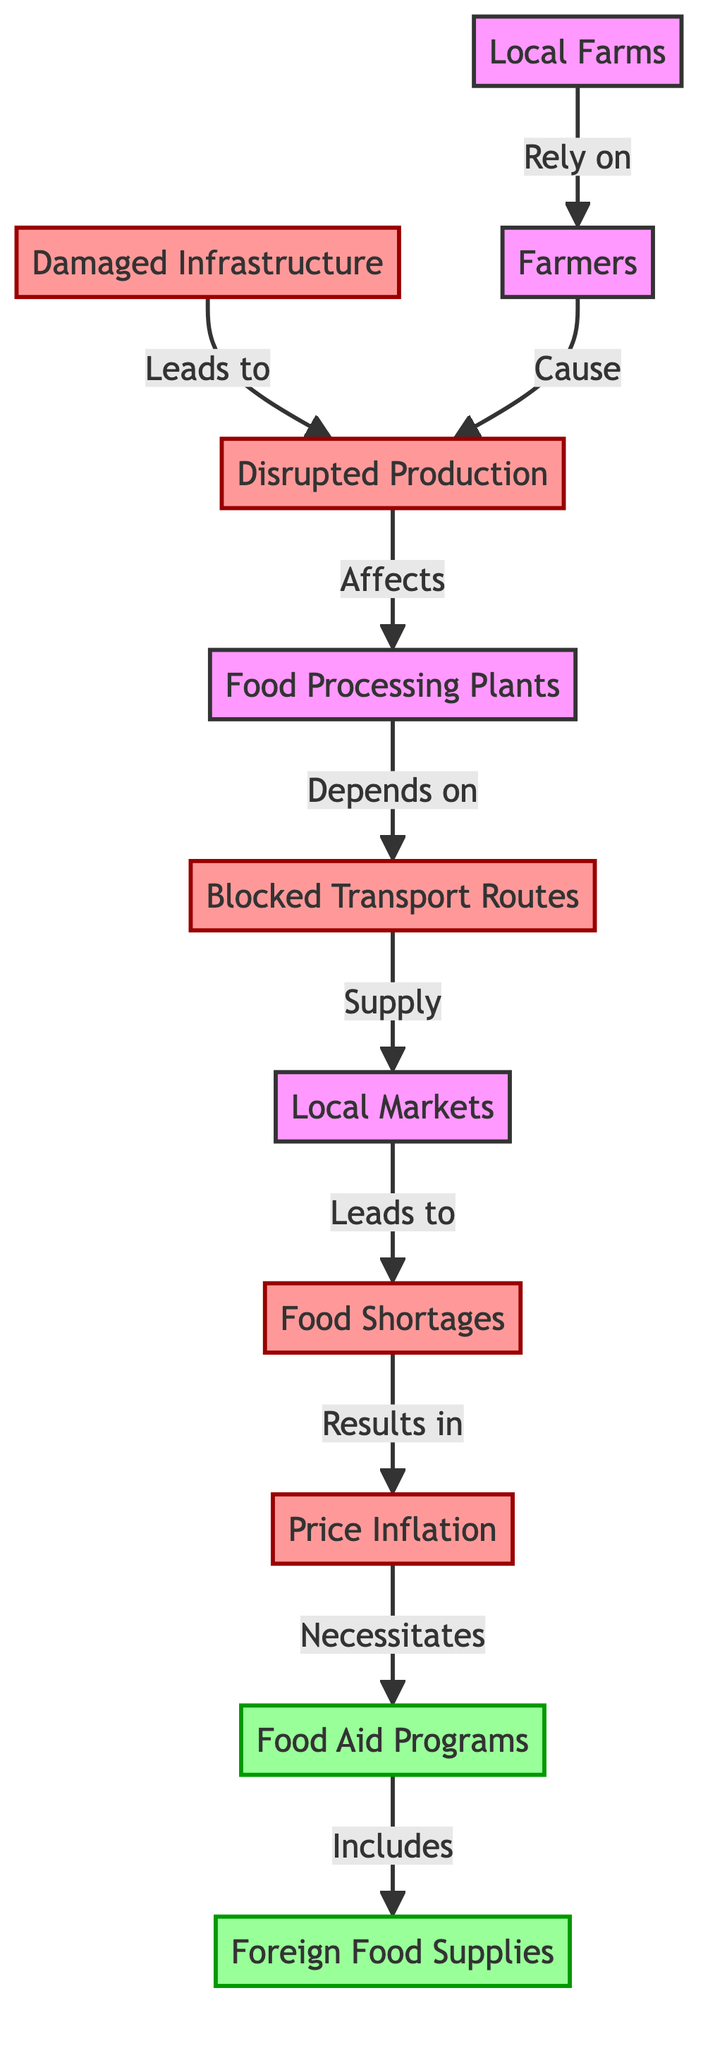What is the first node in the diagram? The first node in the diagram is "Local Farms", which is the starting point for the flow of dependency leading to various impacts due to war.
Answer: Local Farms How many total nodes are there in the diagram? There are a total of 9 nodes represented in the diagram, including "Local Farms", "Farmers", "Damaged Infrastructure", "Disrupted Production", "Food Processing Plants", "Blocked Transport Routes", "Local Markets", "Food Shortages", and "Price Inflation".
Answer: 9 What node is affected by both "Farmers" and "Damaged Infrastructure"? The node affected by both "Farmers" and "Damaged Infrastructure" is "Disrupted Production", as both contribute to the disruption in production.
Answer: Disrupted Production Which node directly leads to "Food Shortages"? The node that directly leads to "Food Shortages" is "Local Markets", as it is the point where the availability of food influences shortages.
Answer: Local Markets What is the relationship between "Price Inflation" and "Food Aid Programs"? The relationship is that "Price Inflation" necessitates "Food Aid Programs", indicating that inflation in food prices triggers the need for external assistance.
Answer: Necessitates Explain how "Blocked Transport Routes" influences food supply. "Blocked Transport Routes" directly influences food supply by hindering the transportation of goods from "Food Processing Plants" to "Local Markets". This blockage can create delays or shortages in food availability, leading to further complications in the supply chain.
Answer: Hinders transportation What do "Food Aid Programs" include according to the diagram? According to the diagram, "Food Aid Programs" include "Foreign Food Supplies", indicating that external supplies are part of the aid provided in response to local shortages.
Answer: Foreign Food Supplies How does "Disrupted Production" affect "Food Processing Plants"? "Disrupted Production" affects "Food Processing Plants" by indicating that the inconsistency or reduction in output from farms impacts the ability of processing plants to operate efficiently, leading to potential shortages or delays in food processing.
Answer: Affects What is the consequence of "Food Shortages" in the diagram? The consequence of "Food Shortages" is "Price Inflation", which suggests that a scarcity of food items causes prices to rise, affecting affordability for consumers.
Answer: Price Inflation 